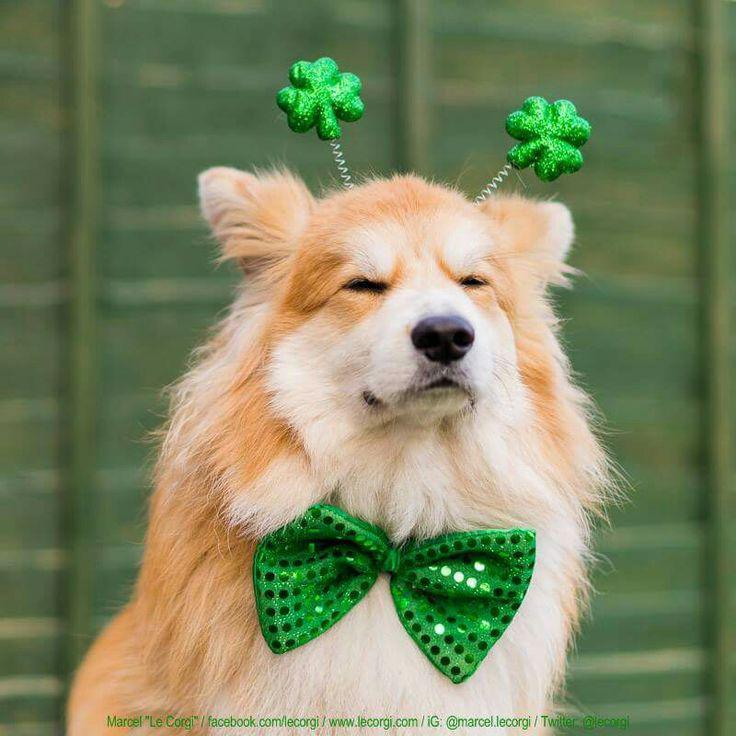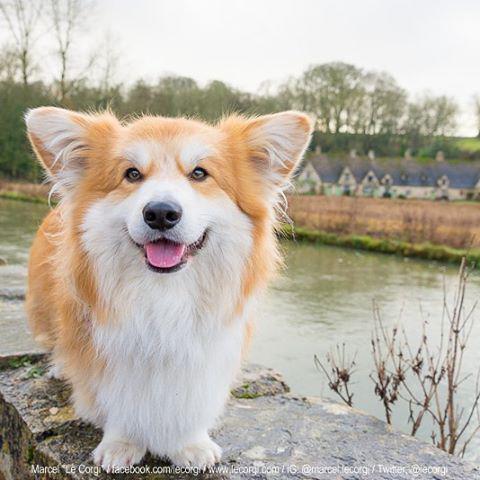The first image is the image on the left, the second image is the image on the right. Examine the images to the left and right. Is the description "One of the dogs is shown with holiday decoration." accurate? Answer yes or no. Yes. The first image is the image on the left, the second image is the image on the right. Evaluate the accuracy of this statement regarding the images: "One photo shows a dog outdoors.". Is it true? Answer yes or no. Yes. 